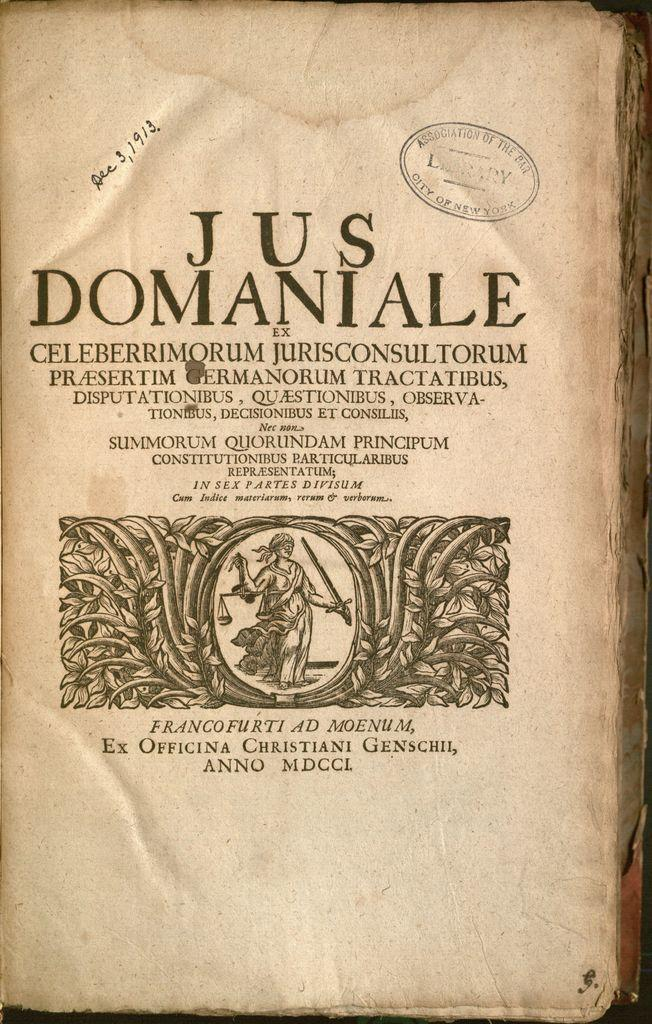<image>
Share a concise interpretation of the image provided. An antique book stamped by the Association of the Bar in New York City has a handwritten date of Dec 3, 1913 in the upper left section. 